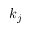<formula> <loc_0><loc_0><loc_500><loc_500>k _ { j }</formula> 